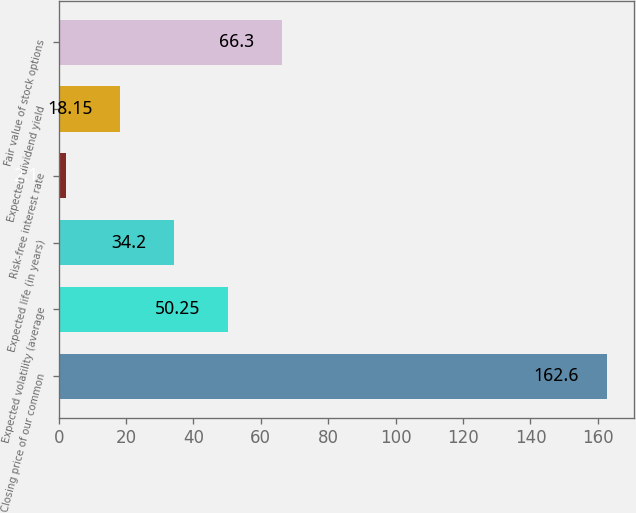Convert chart to OTSL. <chart><loc_0><loc_0><loc_500><loc_500><bar_chart><fcel>Closing price of our common<fcel>Expected volatility (average<fcel>Expected life (in years)<fcel>Risk-free interest rate<fcel>Expected dividend yield<fcel>Fair value of stock options<nl><fcel>162.6<fcel>50.25<fcel>34.2<fcel>2.1<fcel>18.15<fcel>66.3<nl></chart> 